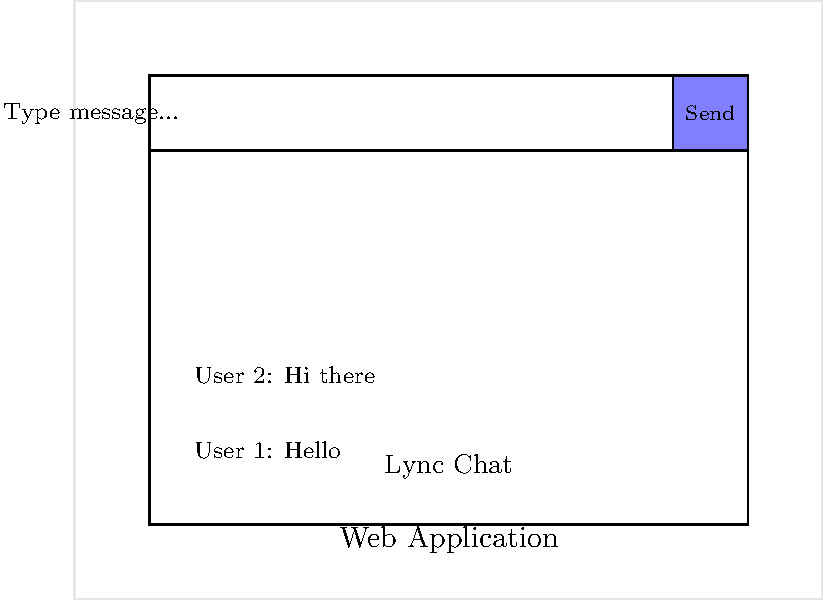Based on the mockup of a web application with integrated Lync chat functionality, which JavaScript API would be most suitable for implementing real-time messaging between users? To implement real-time messaging in a web application with Lync integration, we need to consider the following steps:

1. Lync SDK: Microsoft provides a Lync SDK that includes JavaScript libraries for integrating Lync functionality into web applications.

2. UCWA API: The Unified Communications Web API (UCWA) is part of the Lync SDK and allows web applications to interact with Lync services.

3. Real-time messaging: To implement real-time chat, we need an API that supports instant messaging capabilities.

4. Presence information: The API should also provide user presence status, which is a key feature of Lync.

5. Authentication: The chosen API must support proper authentication to ensure secure communication with Lync services.

6. Event handling: The API should allow for event-driven programming to handle incoming messages and presence changes.

Considering these requirements, the most suitable JavaScript API for implementing real-time messaging between users in a Lync-integrated web application is the Lync Web Developer API. This API, part of the UCWA, provides all the necessary functionality for real-time communication, presence information, and integration with Lync services.
Answer: Lync Web Developer API 